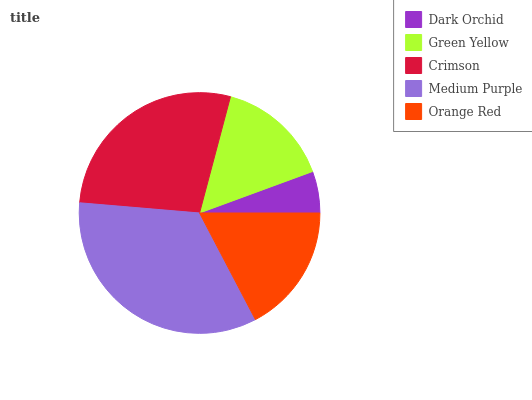Is Dark Orchid the minimum?
Answer yes or no. Yes. Is Medium Purple the maximum?
Answer yes or no. Yes. Is Green Yellow the minimum?
Answer yes or no. No. Is Green Yellow the maximum?
Answer yes or no. No. Is Green Yellow greater than Dark Orchid?
Answer yes or no. Yes. Is Dark Orchid less than Green Yellow?
Answer yes or no. Yes. Is Dark Orchid greater than Green Yellow?
Answer yes or no. No. Is Green Yellow less than Dark Orchid?
Answer yes or no. No. Is Orange Red the high median?
Answer yes or no. Yes. Is Orange Red the low median?
Answer yes or no. Yes. Is Green Yellow the high median?
Answer yes or no. No. Is Crimson the low median?
Answer yes or no. No. 